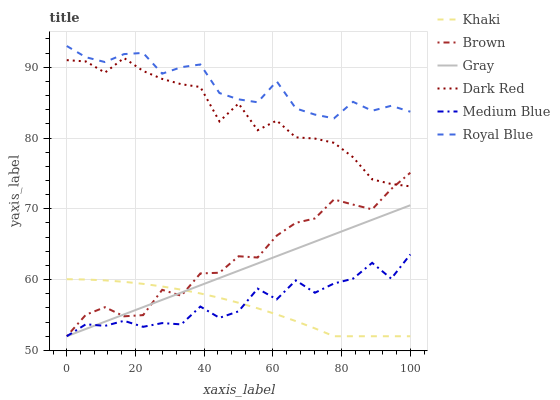Does Khaki have the minimum area under the curve?
Answer yes or no. Yes. Does Royal Blue have the maximum area under the curve?
Answer yes or no. Yes. Does Gray have the minimum area under the curve?
Answer yes or no. No. Does Gray have the maximum area under the curve?
Answer yes or no. No. Is Gray the smoothest?
Answer yes or no. Yes. Is Medium Blue the roughest?
Answer yes or no. Yes. Is Khaki the smoothest?
Answer yes or no. No. Is Khaki the roughest?
Answer yes or no. No. Does Brown have the lowest value?
Answer yes or no. Yes. Does Dark Red have the lowest value?
Answer yes or no. No. Does Royal Blue have the highest value?
Answer yes or no. Yes. Does Gray have the highest value?
Answer yes or no. No. Is Gray less than Royal Blue?
Answer yes or no. Yes. Is Royal Blue greater than Khaki?
Answer yes or no. Yes. Does Medium Blue intersect Brown?
Answer yes or no. Yes. Is Medium Blue less than Brown?
Answer yes or no. No. Is Medium Blue greater than Brown?
Answer yes or no. No. Does Gray intersect Royal Blue?
Answer yes or no. No. 